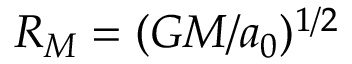Convert formula to latex. <formula><loc_0><loc_0><loc_500><loc_500>R _ { M } = ( G M / a _ { 0 } ) ^ { 1 / 2 }</formula> 